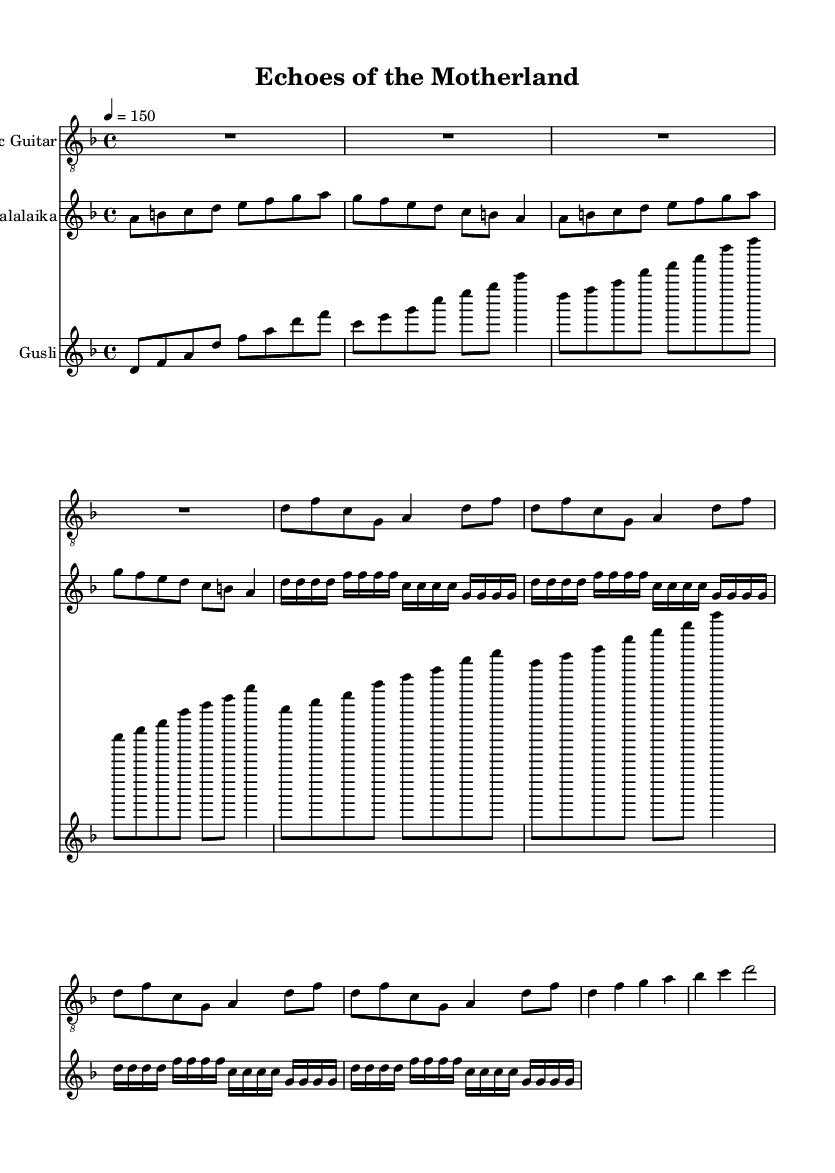What is the key signature of this music? The key signature indicated in the music is D minor, as shown by one flat (B♭) in the key signature at the beginning of the score.
Answer: D minor What is the time signature of this music? The time signature is displayed at the beginning of the first staff and is indicated as 4/4, meaning there are four beats in a measure, and the quarter note gets one beat.
Answer: 4/4 What is the tempo marking of this piece? The tempo marking is specified as 4 = 150, indicating the piece should be played at a speed of 150 beats per minute, with the quarter note receiving the pulse.
Answer: 150 How many bars are there in the verse section? The verse section is repeated four times as indicated by the repeat sign and contains four bars for each repeat, making a total of sixteen bars.
Answer: 16 What type of instrument is playing the main theme in the introduction? The introduction features the electric guitar prominently, as it is the first instrument to play, setting the thematic material for the piece.
Answer: Electric Guitar What kind of play is indicated for the balalaika in the verse section? The balalaika is utilizing a tremolo technique during the verse section, characterized by the rapid alternation of notes, as shown by the notation of repeated sixteenth notes.
Answer: Tremolo What is the texture of the chorus based on the instrumental arrangement? The chorus is primarily arpeggiated, particularly in the gusli, which plays the chords spread out in time rather than simultaneously, creating a fuller sound.
Answer: Arpeggiated 